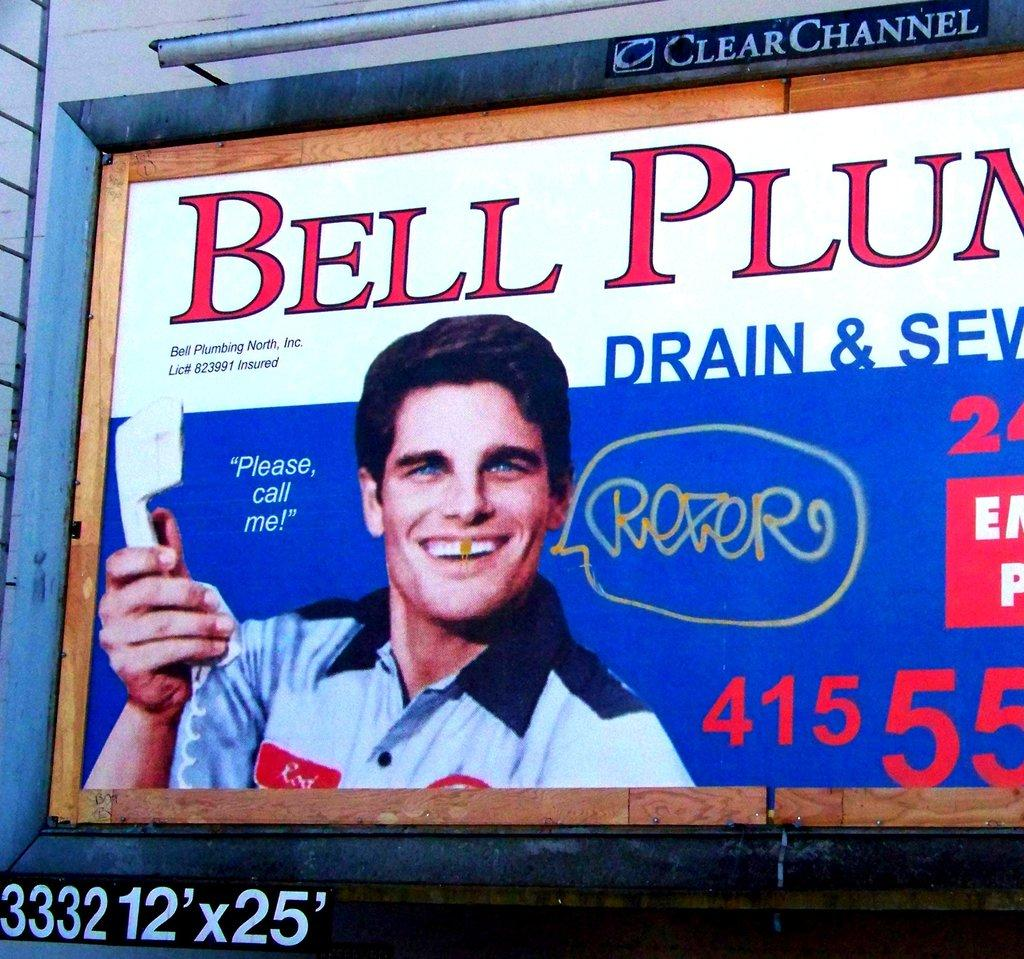<image>
Offer a succinct explanation of the picture presented. A billboard shows advertisement about Bell Plumbing with a guy holding a phone. 